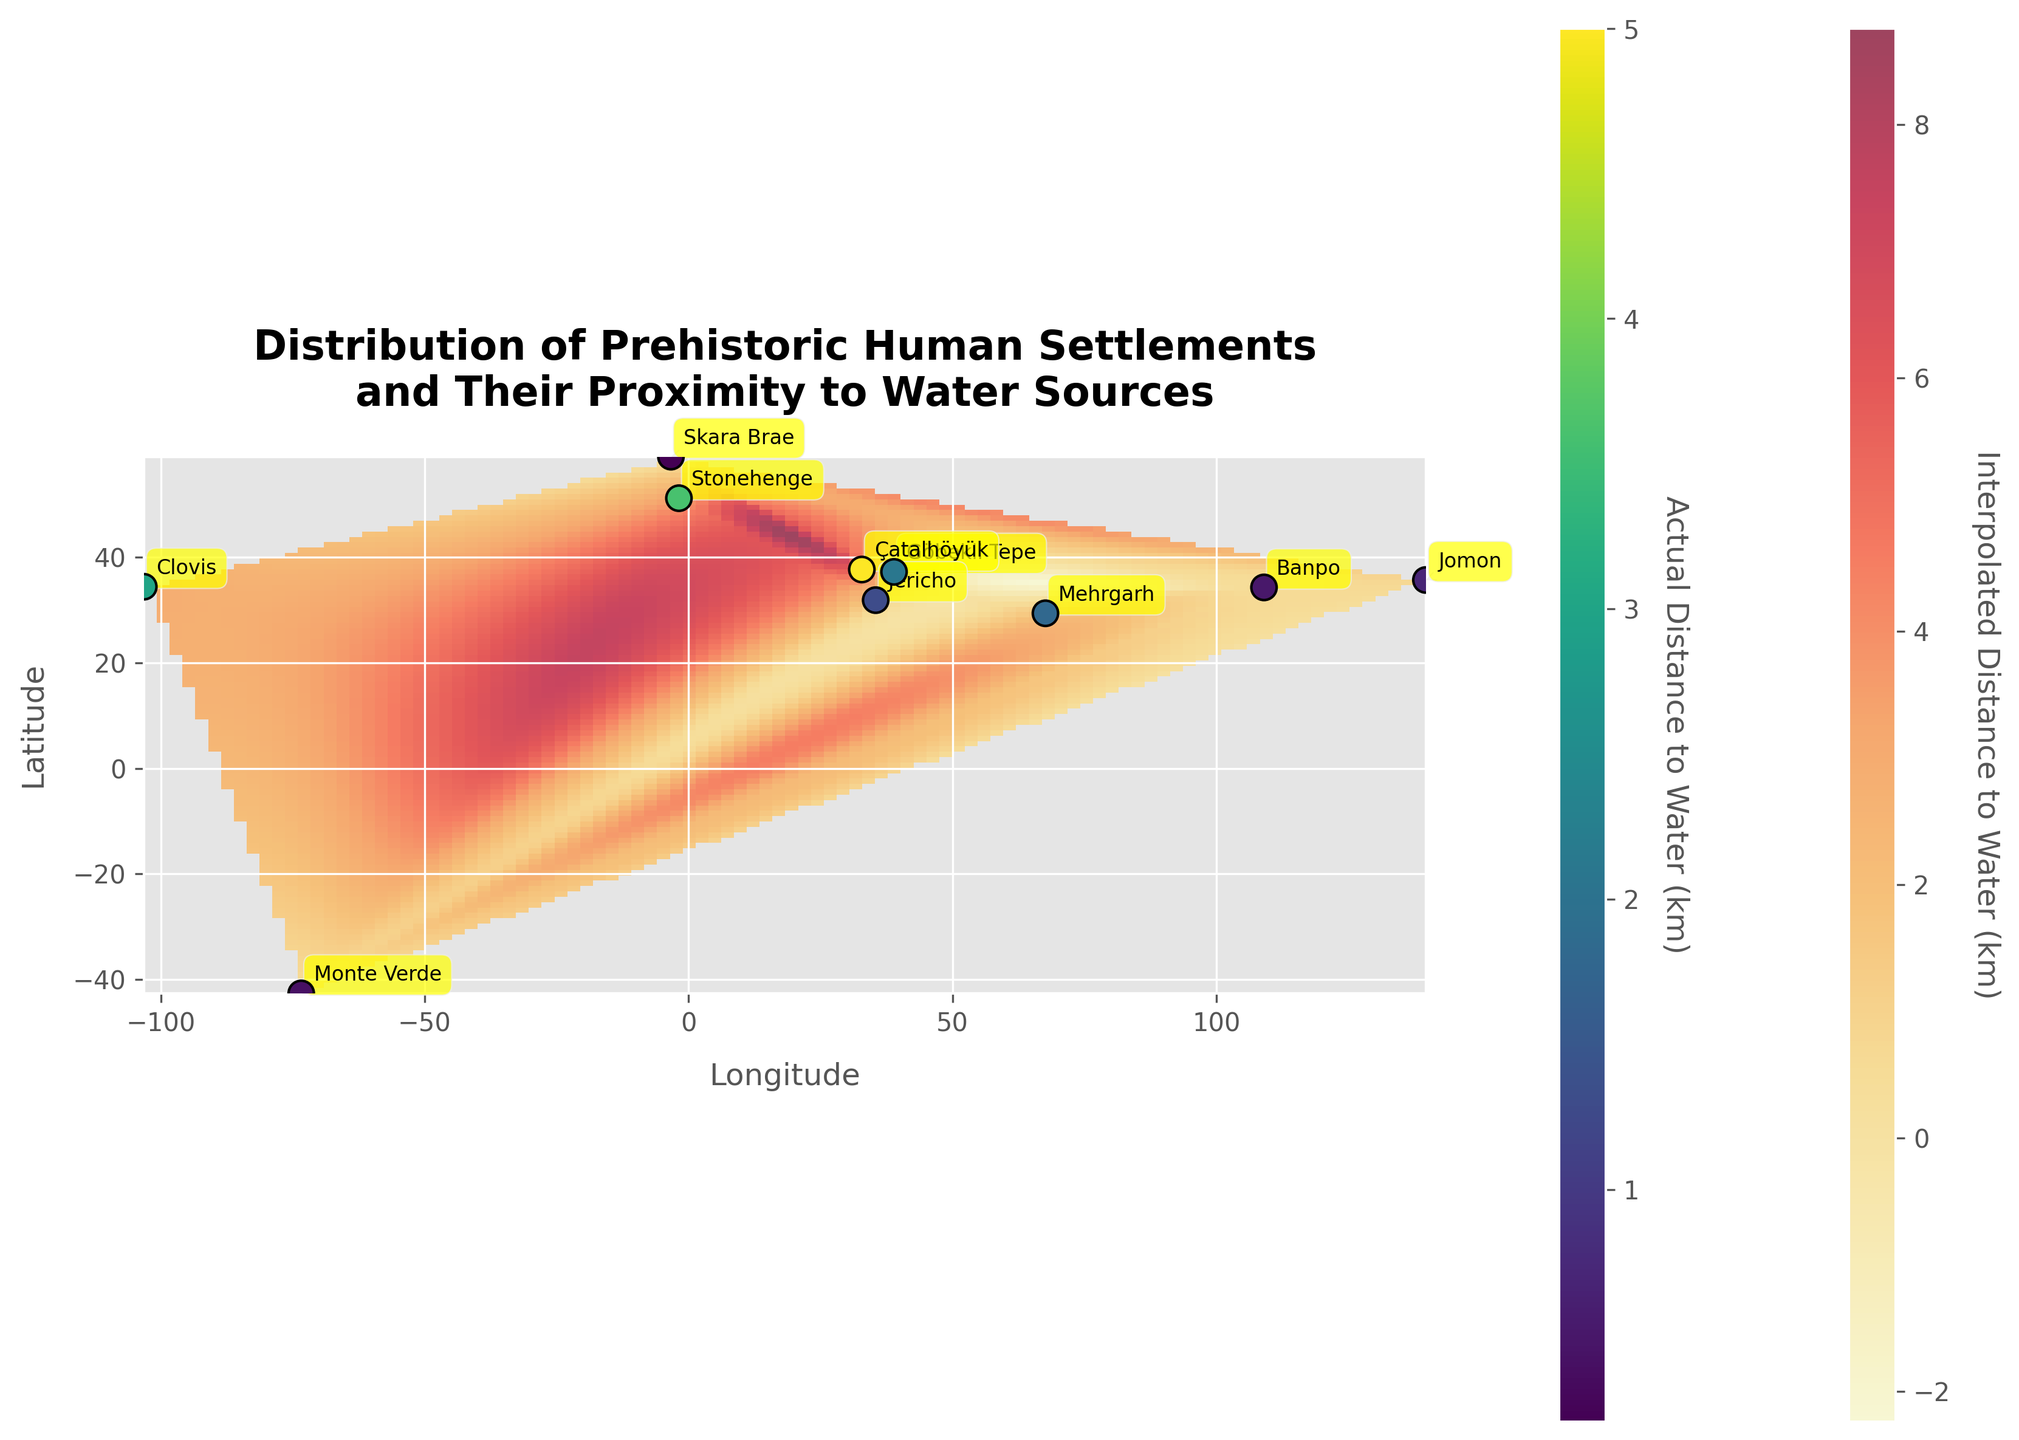How many prehistoric human settlements are shown on the heatmap? Count the number of settlements annotated on the heatmap.
Answer: 10 What is the title of the heatmap? Read the centrally placed title text on the top of the heatmap.
Answer: Distribution of Prehistoric Human Settlements and Their Proximity to Water Sources Which settlement is located closest to a water source? Identify the settlement with the smallest distance value in the color bar for scatter points.
Answer: Skara Brae Which settlements are more than 3 km away from their nearest water source? Identify the settlements with distances greater than 3.0 km by checking the color of the scatter points and corresponding annotations.
Answer: Çatalhöyük, Stonehenge, Clovis What is the average distance to the nearest water source for all settlements? Sum the distances and divide by the number of settlements: (2.1 + 5.0 + 1.3 + 1.8 + 0.2 + 3.6 + 0.4 + 0.5 + 0.7 + 3.0) / 10.
Answer: 1.86 km Which settlement is closer to a water source: Jericho or Monte Verde? Compare the distances annotated next to Jericho and Monte Verde.
Answer: Jericho Which settlement has the longest distance to the nearest water source? Identify the settlement with the largest distance value in the color bar for scatter points.
Answer: Çatalhöyük How does the color intensity of the heatmap vary as the distance to the nearest water source increases? Observe the color transition in the heatmap as distance increases, particularly from shades of yellow to red.
Answer: It becomes more intense (darker red) with increasing distance What is the range of latitudes covered by the settlements on the map? Check the minimum and maximum latitude values indicated along the Y-axis.
Answer: -42.6311 to 59.0489 Which settlement is located at the highest latitude? Identify the settlement with the highest latitude value on the Y-axis.
Answer: Skara Brae 